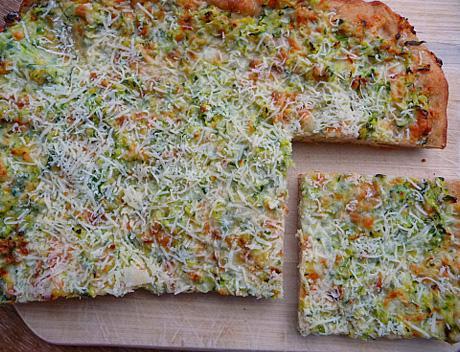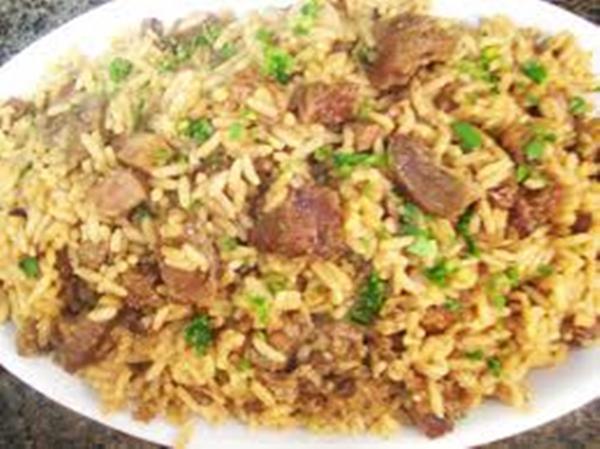The first image is the image on the left, the second image is the image on the right. Evaluate the accuracy of this statement regarding the images: "At least one pizza has a slice cut out of it.". Is it true? Answer yes or no. Yes. The first image is the image on the left, the second image is the image on the right. Analyze the images presented: Is the assertion "The left and right image contains the same number of circle shaped pizzas." valid? Answer yes or no. No. 